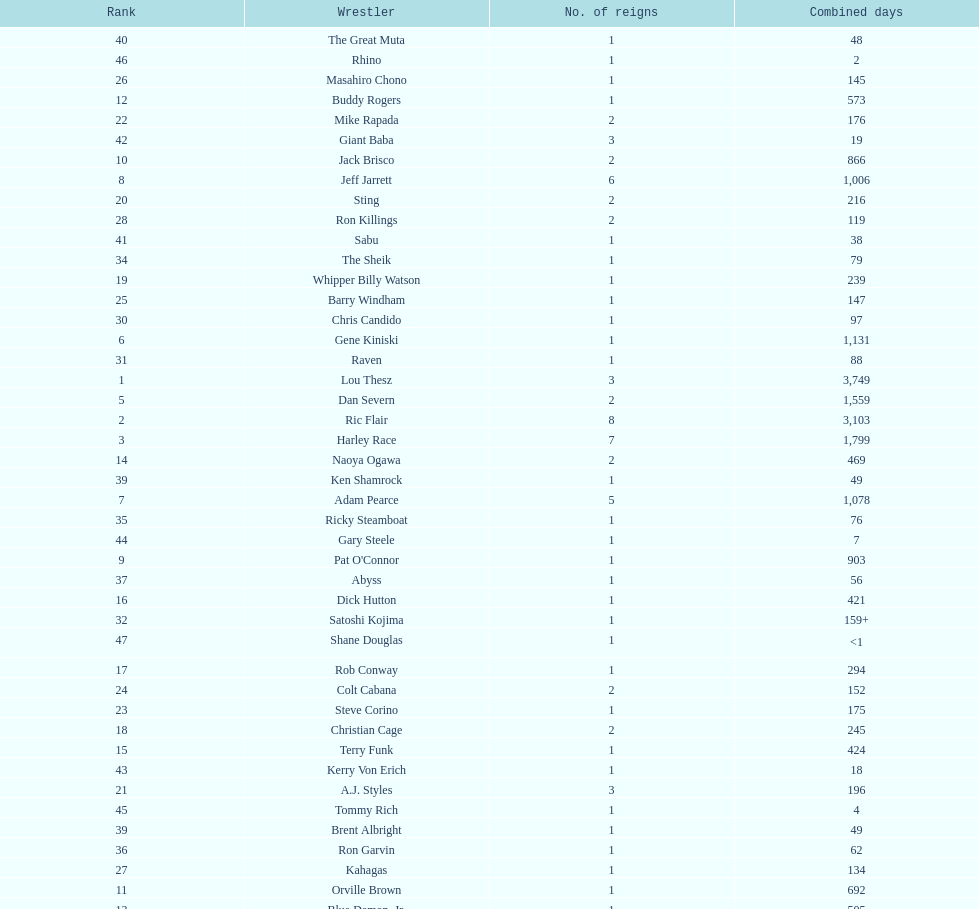Who has spent more time as nwa world heavyyweight champion, gene kiniski or ric flair? Ric Flair. 